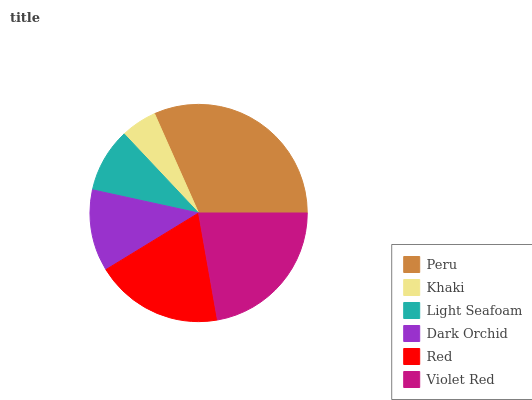Is Khaki the minimum?
Answer yes or no. Yes. Is Peru the maximum?
Answer yes or no. Yes. Is Light Seafoam the minimum?
Answer yes or no. No. Is Light Seafoam the maximum?
Answer yes or no. No. Is Light Seafoam greater than Khaki?
Answer yes or no. Yes. Is Khaki less than Light Seafoam?
Answer yes or no. Yes. Is Khaki greater than Light Seafoam?
Answer yes or no. No. Is Light Seafoam less than Khaki?
Answer yes or no. No. Is Red the high median?
Answer yes or no. Yes. Is Dark Orchid the low median?
Answer yes or no. Yes. Is Peru the high median?
Answer yes or no. No. Is Violet Red the low median?
Answer yes or no. No. 